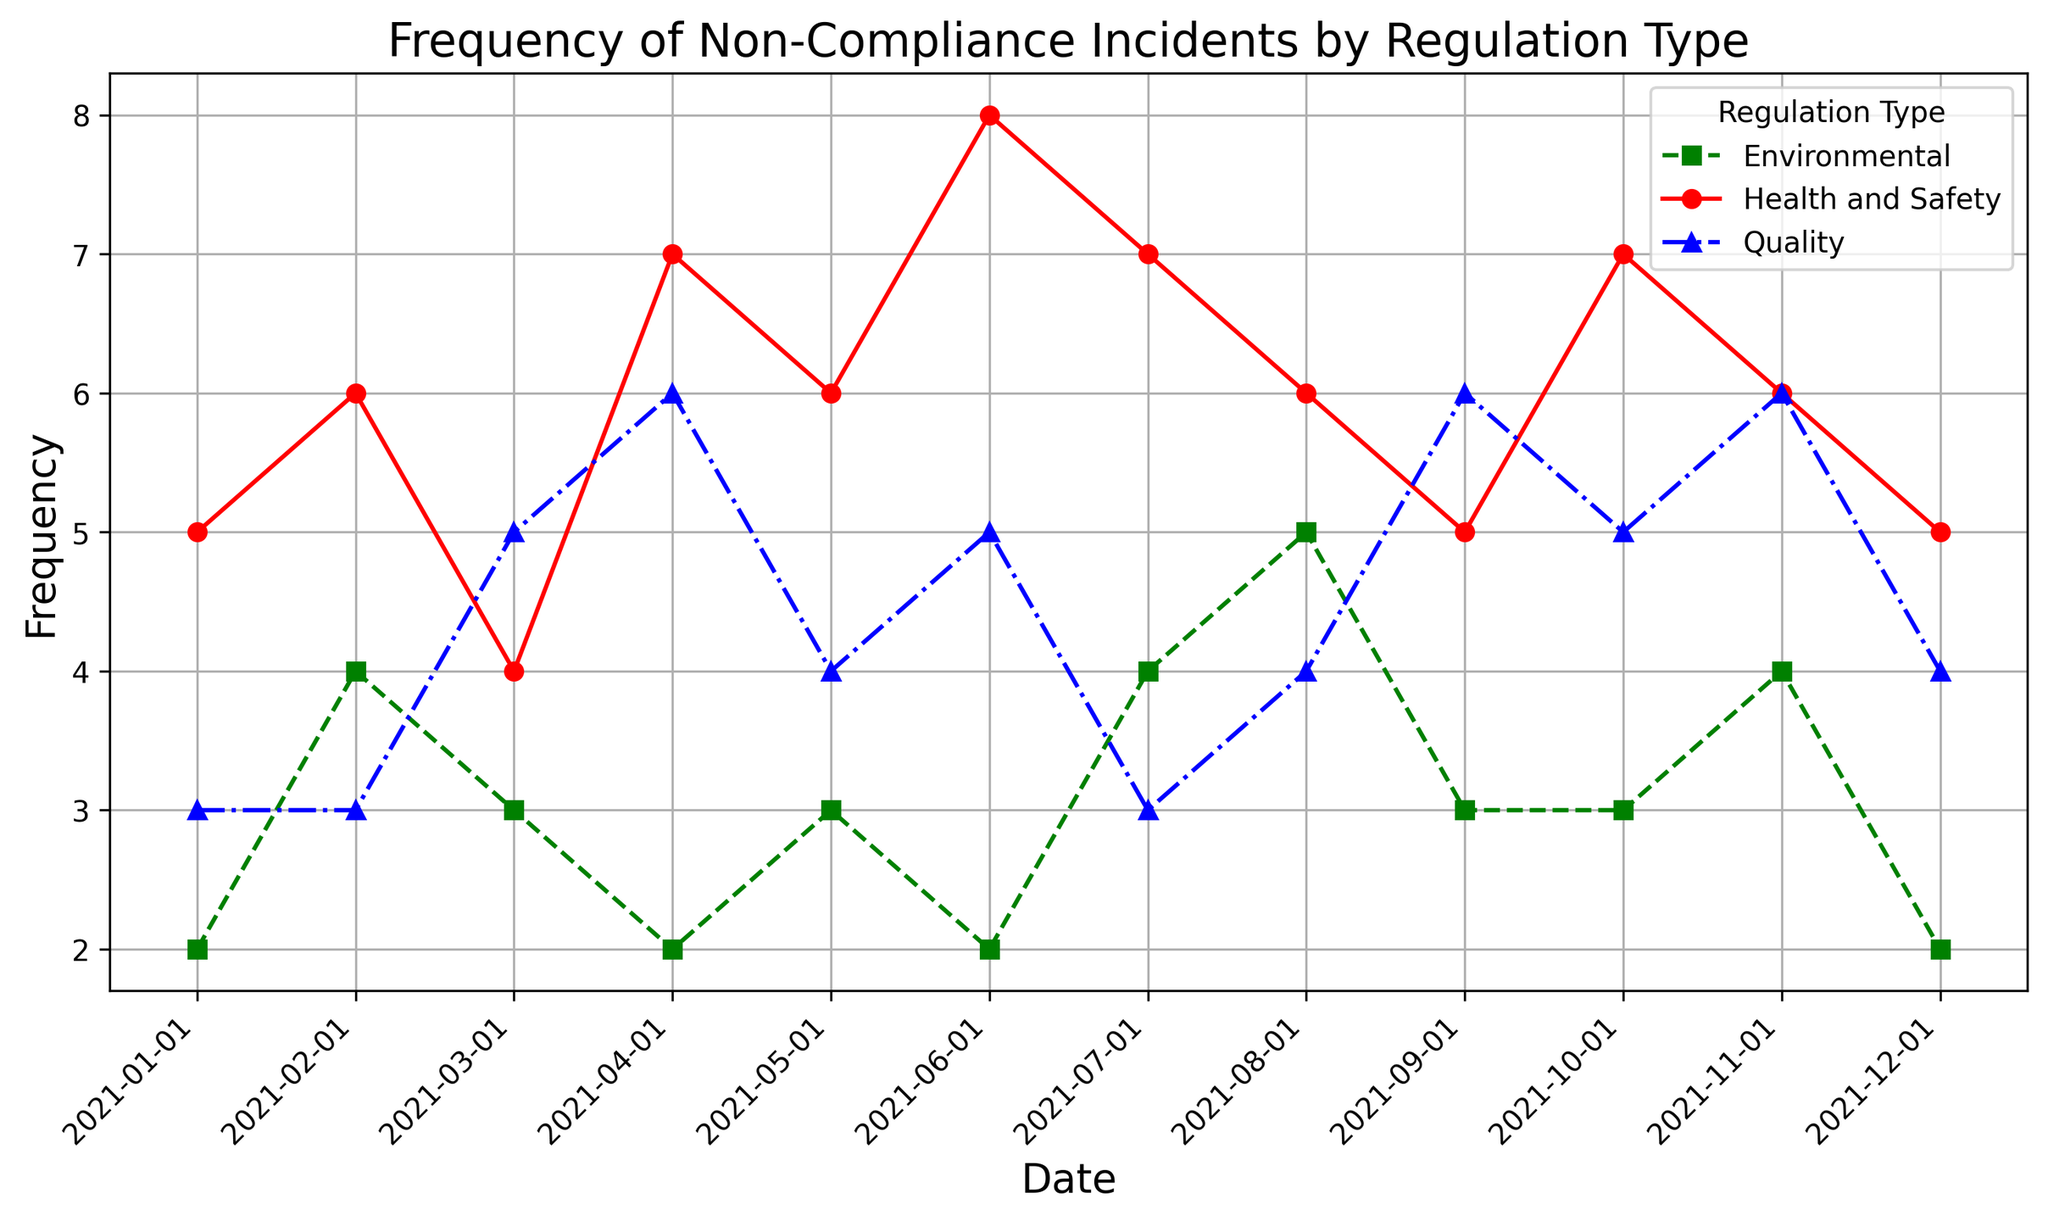What is the frequency of Health and Safety non-compliance incidents in June 2021? Look at the red line marked with circles specifically under the date June 2021 and read the frequency value.
Answer: 8 Which regulation type had the highest number of non-compliance incidents in May 2021? Compare the frequencies for each regulation type in May 2021 by looking at their respective lines and markers. The highest one will indicate the regulation type.
Answer: Health and Safety How has the frequency of Environmental non-compliance incidents changed from January 2021 to December 2021? Trace the green line marked with squares from January 2021 to December 2021 and note the starting and ending values. Calculate the change by subtracting the initial value from the final value.
Answer: It decreased from 2 to 2, therefore no change Which month shows the highest spike in Quality non-compliance incidents? Look at the blue line marked with triangles and observe any sharp increases. Identify the month when this maximum spike occurs.
Answer: April 2021 Between March 2021 and July 2021, which regulation type shows the least variability in non-compliance incident frequency? Examine the three lines between March 2021 and July 2021, checking for the one with the smallest fluctuations (least ups and downs).
Answer: Quality Summarize the trend in Health and Safety non-compliance incidents over the year 2021. Follow the red line from January 2021 to December 2021 to observe the overall pattern or trend, noting any general increases, decreases, or consistent periods.
Answer: General upward trend with fluctuations On average, how many Environmental non-compliance incidents occurred per month in 2021? Sum the monthly frequencies of Environmental non-compliance incidents from January 2021 to December 2021 and divide by 12 (total number of months).
Answer: (2 + 4 + 3 + 2 + 3 + 2 + 4 + 5 + 3 + 3 + 4 + 2) / 12 = 3.0833 (approximately 3) Between which two consecutive months did Health and Safety incidents decline the most? Observe the red line for the points where it decreases the most between consecutive months and note those months.
Answer: April to May 2021 